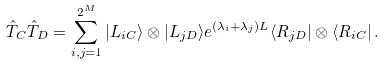<formula> <loc_0><loc_0><loc_500><loc_500>\hat { T } _ { C } \hat { T } _ { D } = \sum _ { i , j = 1 } ^ { 2 ^ { M } } | L _ { i C } \rangle \otimes | L _ { j D } \rangle e ^ { ( \lambda _ { i } + \lambda _ { j } ) L } \langle R _ { j D } | \otimes \langle R _ { i C } | \, .</formula> 